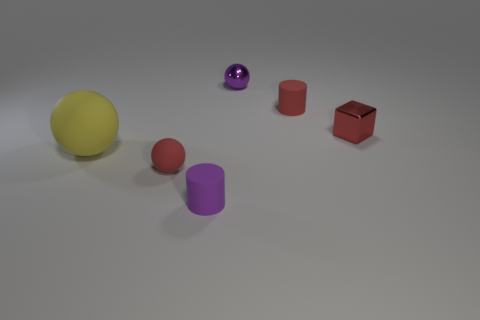Add 1 tiny cylinders. How many objects exist? 7 Subtract all blocks. How many objects are left? 5 Subtract all metallic cubes. Subtract all small matte objects. How many objects are left? 2 Add 5 red rubber things. How many red rubber things are left? 7 Add 3 purple metallic objects. How many purple metallic objects exist? 4 Subtract 0 brown blocks. How many objects are left? 6 